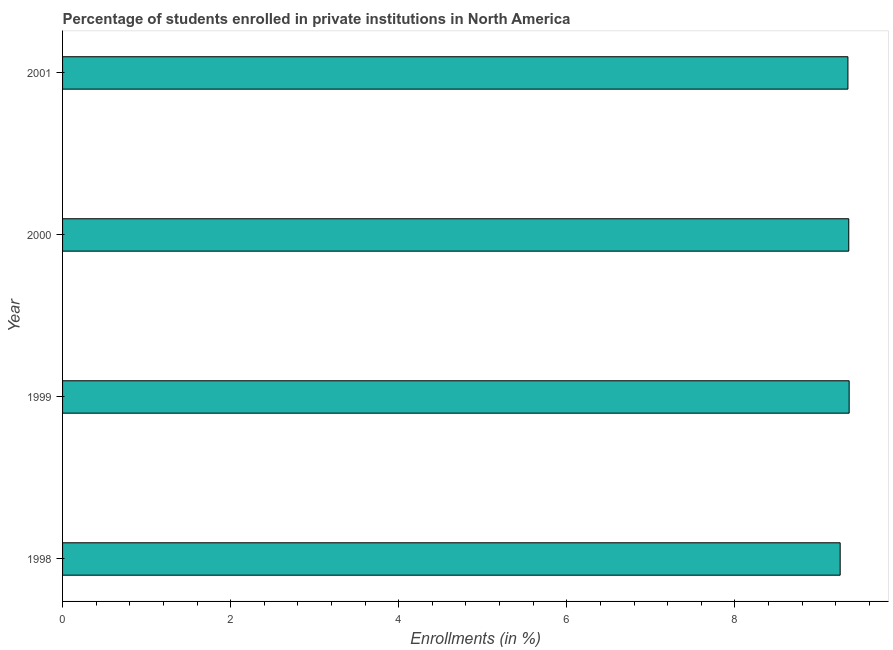Does the graph contain any zero values?
Your answer should be very brief. No. Does the graph contain grids?
Ensure brevity in your answer.  No. What is the title of the graph?
Offer a terse response. Percentage of students enrolled in private institutions in North America. What is the label or title of the X-axis?
Give a very brief answer. Enrollments (in %). What is the label or title of the Y-axis?
Your answer should be very brief. Year. What is the enrollments in private institutions in 1999?
Your response must be concise. 9.36. Across all years, what is the maximum enrollments in private institutions?
Your response must be concise. 9.36. Across all years, what is the minimum enrollments in private institutions?
Offer a terse response. 9.25. In which year was the enrollments in private institutions maximum?
Keep it short and to the point. 1999. In which year was the enrollments in private institutions minimum?
Provide a short and direct response. 1998. What is the sum of the enrollments in private institutions?
Provide a succinct answer. 37.32. What is the difference between the enrollments in private institutions in 1999 and 2000?
Provide a short and direct response. 0.01. What is the average enrollments in private institutions per year?
Offer a terse response. 9.33. What is the median enrollments in private institutions?
Make the answer very short. 9.35. What is the ratio of the enrollments in private institutions in 1998 to that in 2000?
Offer a very short reply. 0.99. Is the enrollments in private institutions in 2000 less than that in 2001?
Your answer should be very brief. No. What is the difference between the highest and the second highest enrollments in private institutions?
Make the answer very short. 0.01. Is the sum of the enrollments in private institutions in 1999 and 2001 greater than the maximum enrollments in private institutions across all years?
Your answer should be compact. Yes. What is the difference between the highest and the lowest enrollments in private institutions?
Ensure brevity in your answer.  0.11. How many bars are there?
Your answer should be very brief. 4. How many years are there in the graph?
Offer a very short reply. 4. What is the difference between two consecutive major ticks on the X-axis?
Offer a terse response. 2. What is the Enrollments (in %) of 1998?
Give a very brief answer. 9.25. What is the Enrollments (in %) in 1999?
Provide a short and direct response. 9.36. What is the Enrollments (in %) in 2000?
Provide a succinct answer. 9.36. What is the Enrollments (in %) in 2001?
Your response must be concise. 9.35. What is the difference between the Enrollments (in %) in 1998 and 1999?
Give a very brief answer. -0.11. What is the difference between the Enrollments (in %) in 1998 and 2000?
Provide a short and direct response. -0.1. What is the difference between the Enrollments (in %) in 1998 and 2001?
Give a very brief answer. -0.09. What is the difference between the Enrollments (in %) in 1999 and 2000?
Provide a succinct answer. 0. What is the difference between the Enrollments (in %) in 1999 and 2001?
Offer a very short reply. 0.01. What is the difference between the Enrollments (in %) in 2000 and 2001?
Keep it short and to the point. 0.01. What is the ratio of the Enrollments (in %) in 1998 to that in 1999?
Your answer should be compact. 0.99. What is the ratio of the Enrollments (in %) in 2000 to that in 2001?
Provide a short and direct response. 1. 